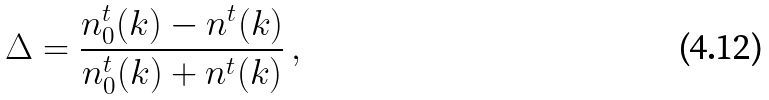<formula> <loc_0><loc_0><loc_500><loc_500>\Delta = \frac { n ^ { t } _ { 0 } ( k ) - n ^ { t } ( k ) } { n ^ { t } _ { 0 } ( k ) + n ^ { t } ( k ) } \, ,</formula> 